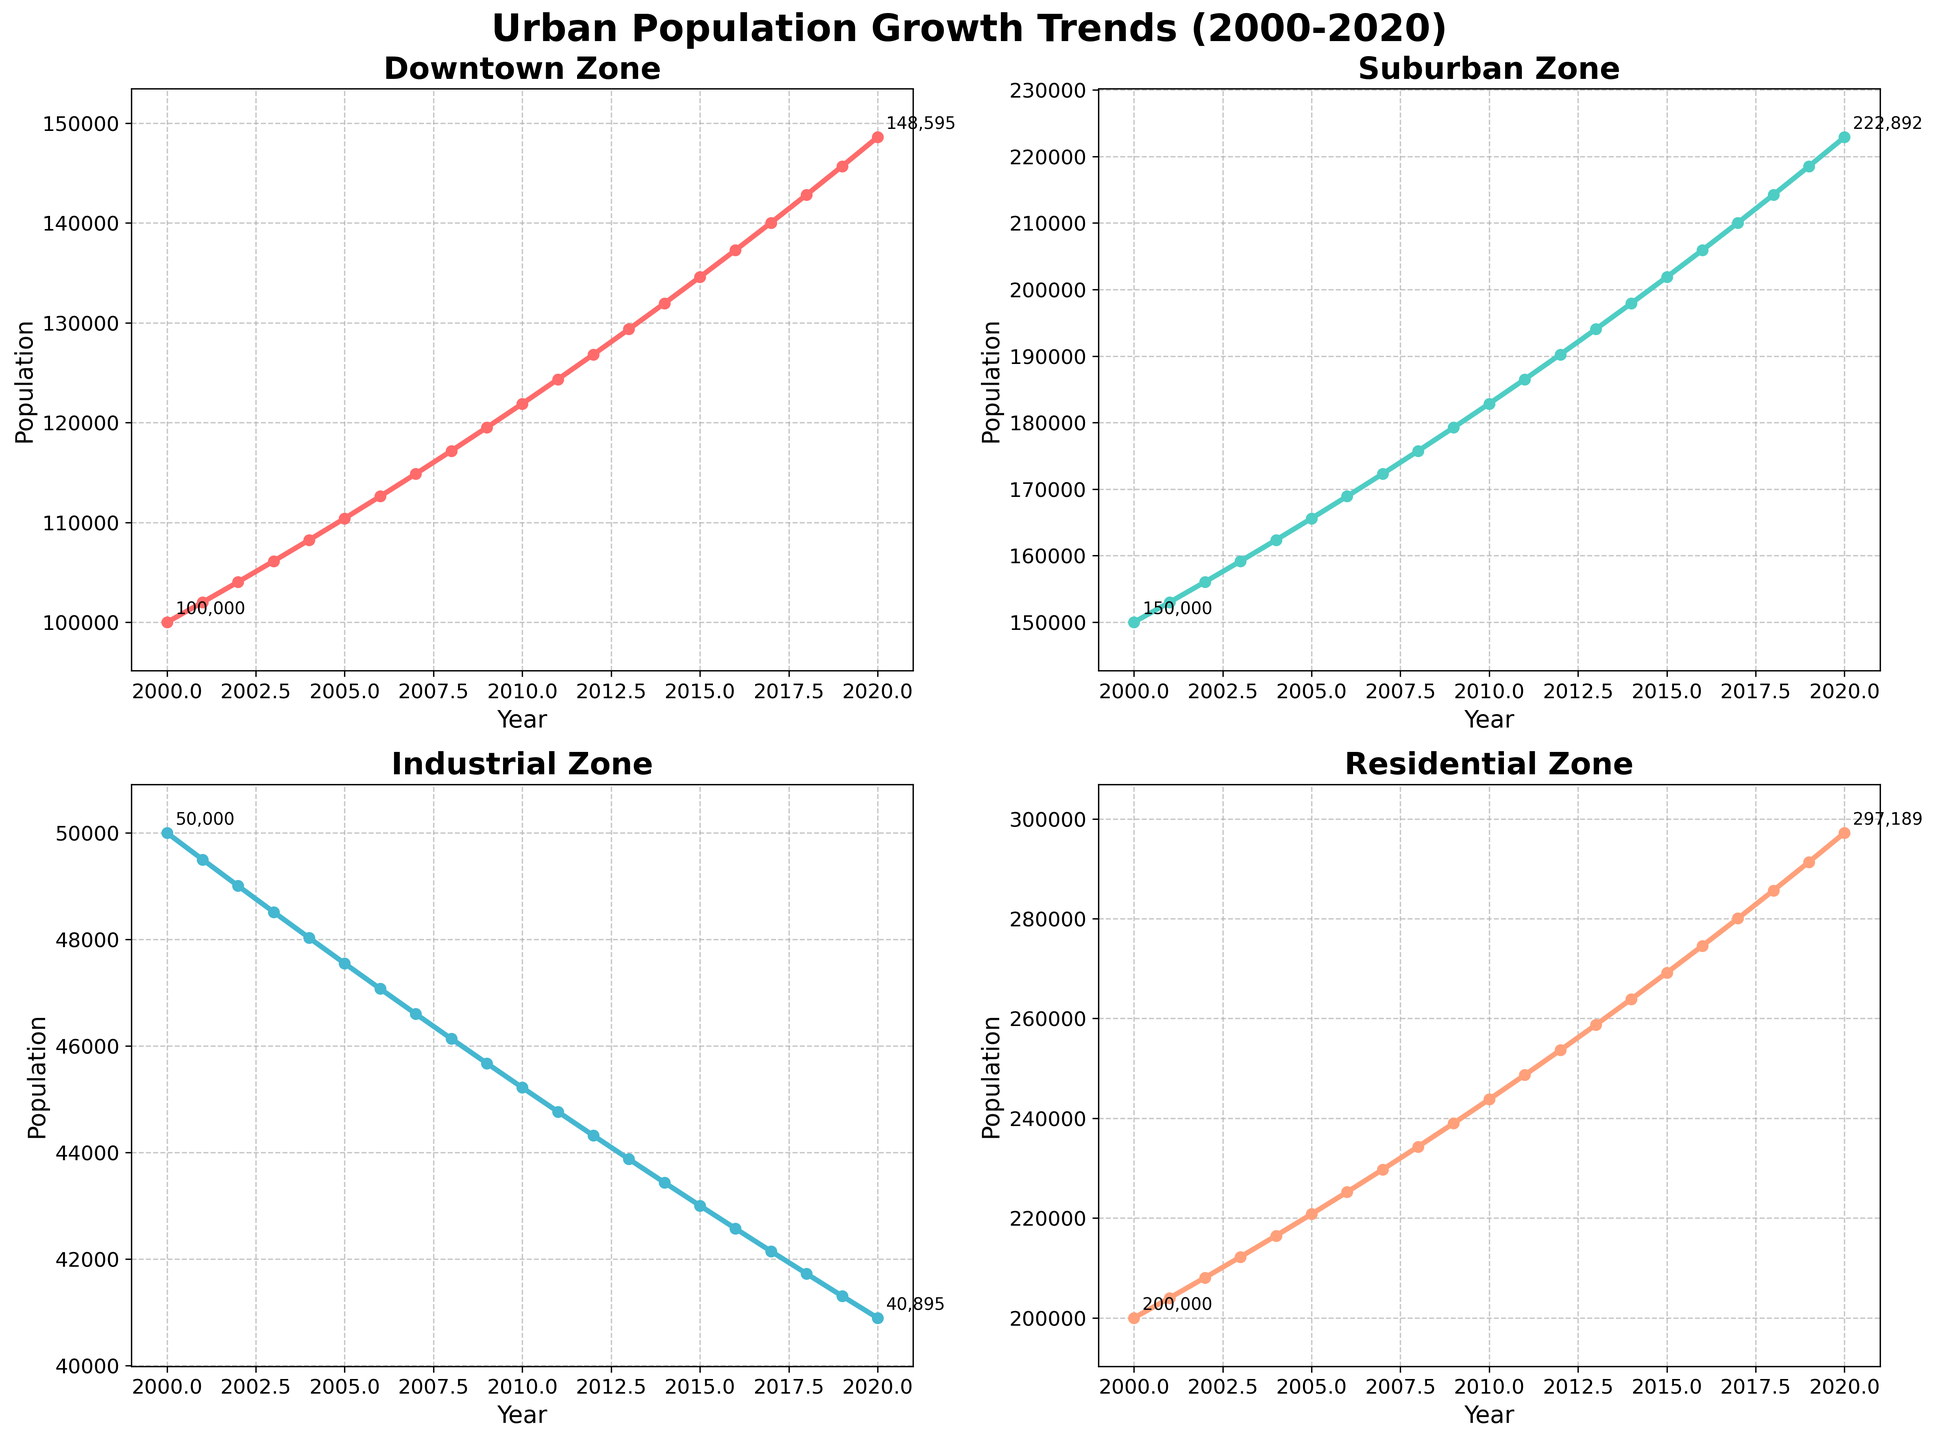What's the population difference between the Downtown and Suburban zones in 2020? In the figure, the population of the Downtown zone in 2020 is 148,595 and the population of the Suburban zone in 2020 is 222,892. The difference is calculated by subtracting the Downtown population from the Suburban population, which is 222,892 - 148,595 = 74,297.
Answer: 74,297 Which zone experienced the highest population growth in absolute terms from 2000 to 2020? To determine which zone experienced the highest population growth, we need to find the difference between the population values for each zone in 2000 and 2020. For the Downtown zone, the growth is 148,595 - 100,000 = 48,595. For the Suburban zone, it's 222,892 - 150,000 = 72,892. For the Industrial zone, it's 40,895 - 50,000 = -9,105. For the Residential zone, it's 297,189 - 200,000 = 97,189. The Residential zone experienced the highest population growth.
Answer: Residential What was the average population in the Industrial zone from 2000 to 2020? To find the average population, we sum the population of the Industrial zone for each year and divide by the number of years (21 years). The total population from 2000 to 2020 is 50,000 + 49,500 + 49,005 + 48,515 + 48,030 + 47,549 + 47,074 + 46,603 + 46,137 + 45,676 + 45,219 + 44,767 + 44,319 + 43,876 + 43,437 + 43,003 + 42,573 + 42,147 + 41,726 + 41,308 + 40,895 = 1,016,479. The average is 1,016,479 / 21 ≈ 48,404.
Answer: 48,404 Is the population trend in the Residential zone continuously increasing over the years? By examining the plotted line for the Residential zone, we can observe that the population value increases each year from 2000 (200,000) to 2020 (297,189) without any decreases or plateaus. Therefore, the population trend in the Residential zone is continuously increasing.
Answer: Yes Which zone had the lowest population in 2010? By checking the population values for each zone in 2010 from the plotted lines, we see that the Downtown zone had 121,899 people, the Suburban zone had 182,849 people, the Industrial zone had 45,219 people, and the Residential zone had 243,799 people. The Industrial zone had the lowest population in 2010.
Answer: Industrial What is the population ratio between the Suburban and Industrial zones in 2005? In 2005, the population of the Suburban zone is 165,612 and the population of the Industrial zone is 47,549. The ratio is calculated by dividing the Suburban population by the Industrial population, which is 165,612 / 47,549 ≈ 3.48.
Answer: 3.48 Did any zone experience a decrease in population at any point from 2000 to 2020? By examining the trends in the plotted lines for all zones, it is observed that the Industrial zone experienced a continuous decline in population over the years while all other zones showed population growth. Hence, the Industrial zone experienced a decrease in population.
Answer: Yes What is the total population increase in the Downtown zone from 2000 to 2010? The population in the Downtown zone was 100,000 in 2000 and increased to 121,899 in 2010. The total increase is calculated as 121,899 - 100,000 = 21,899.
Answer: 21,899 